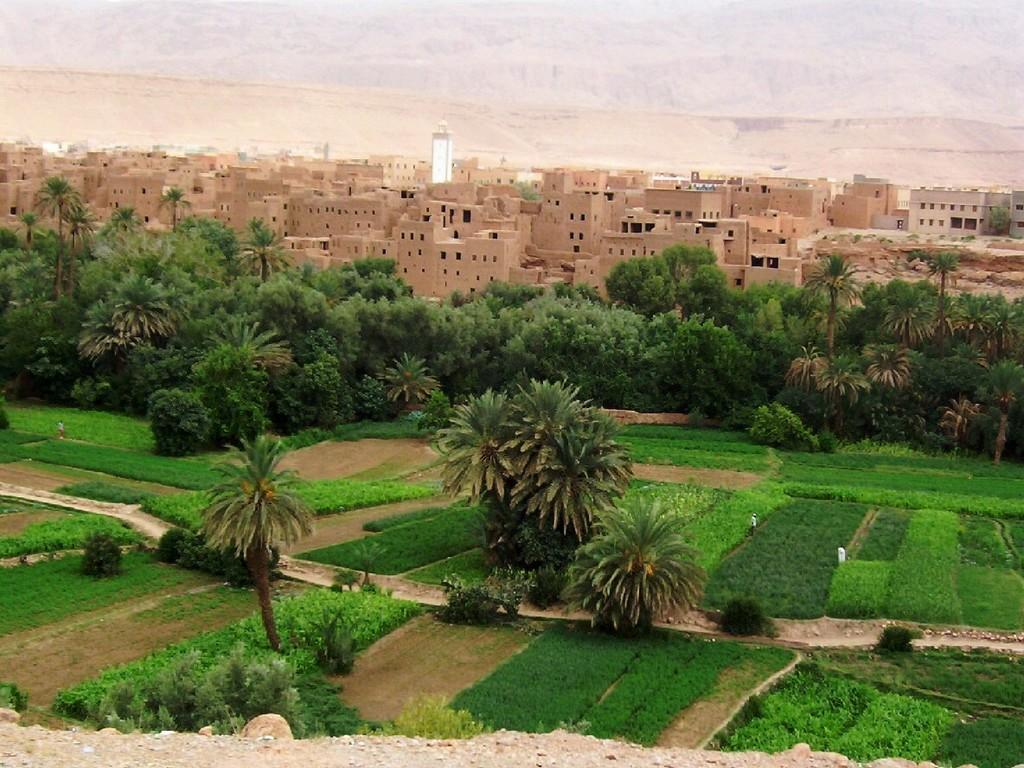Could you give a brief overview of what you see in this image? In this image I see the green grass, trees and plants in the front. In the background I see the buildings and I see a tower over here. 